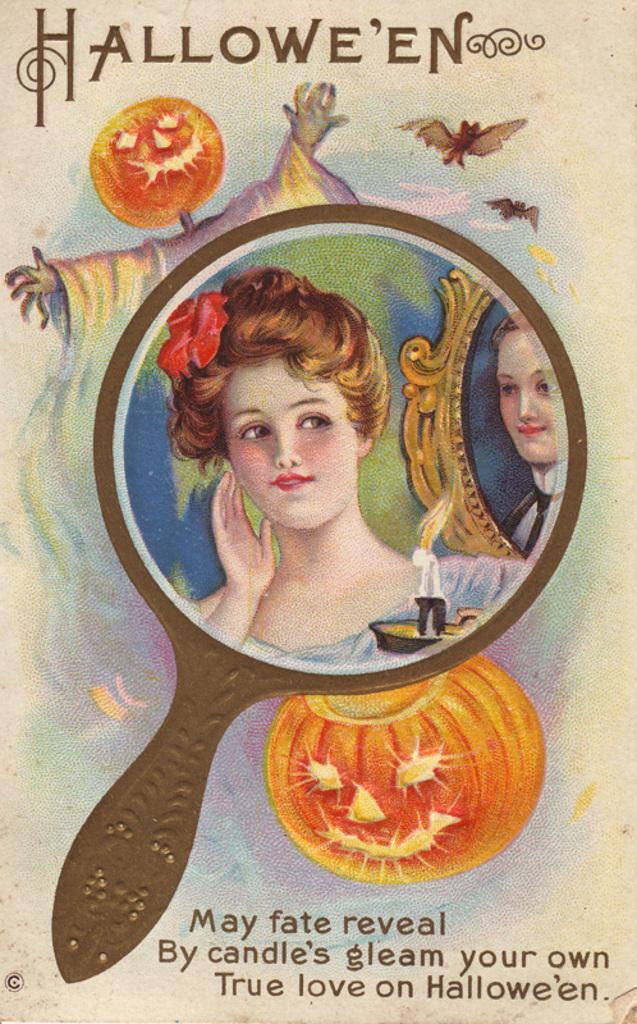Please provide a concise description of this image. In this picture I can see a poster, there are words and images on the poster. 